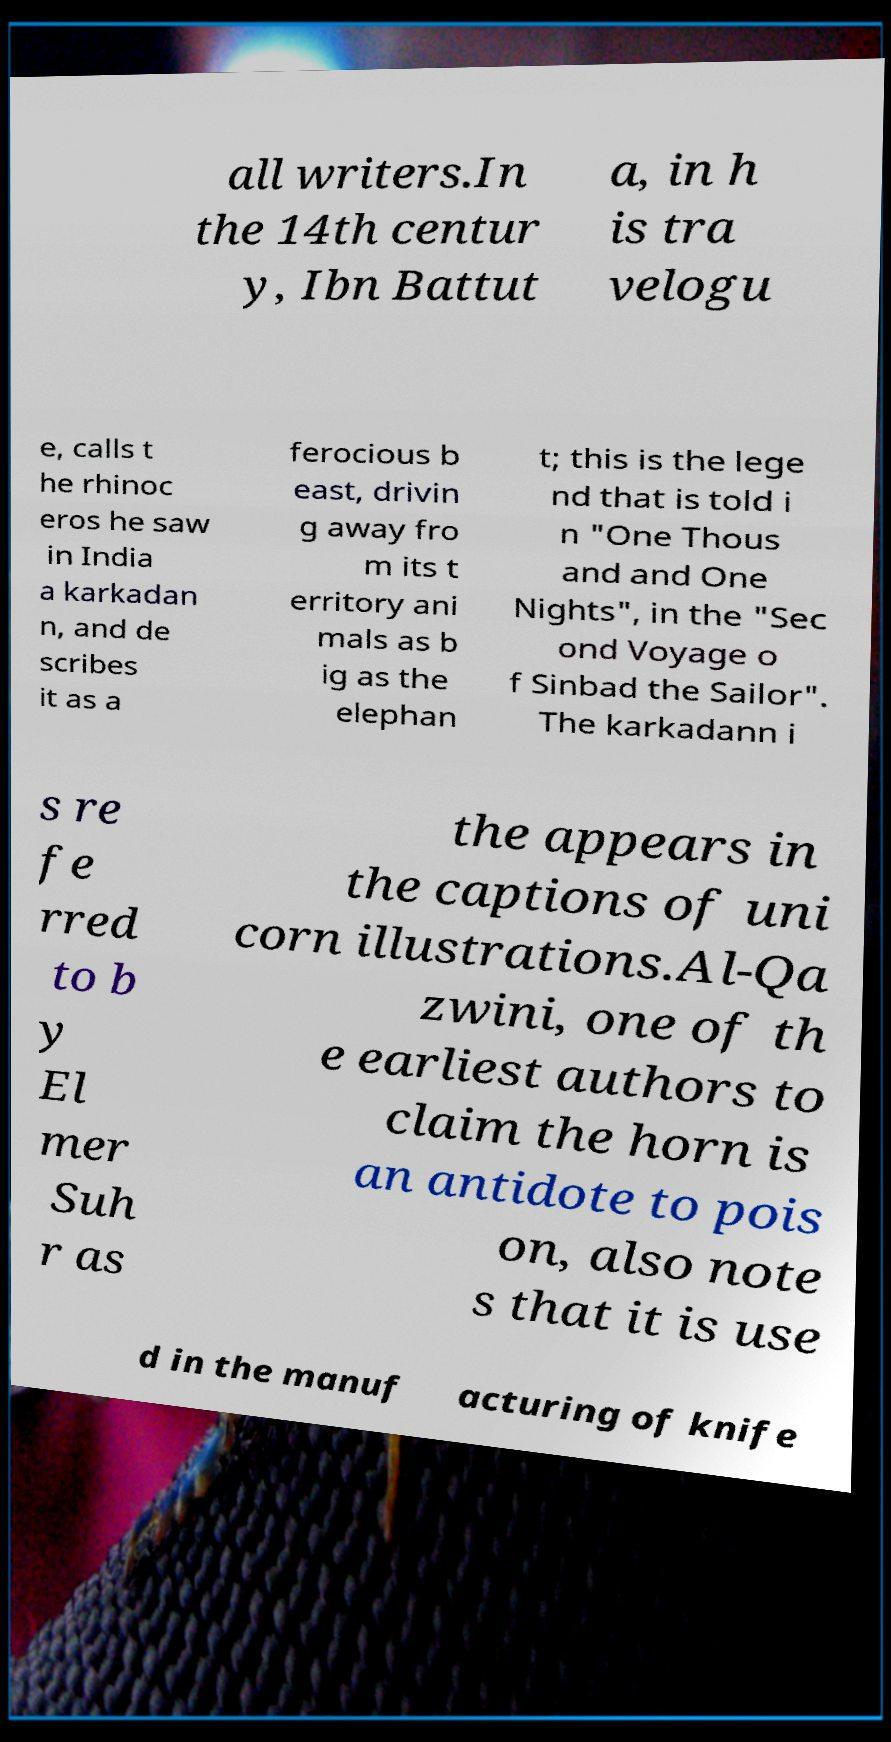What messages or text are displayed in this image? I need them in a readable, typed format. all writers.In the 14th centur y, Ibn Battut a, in h is tra velogu e, calls t he rhinoc eros he saw in India a karkadan n, and de scribes it as a ferocious b east, drivin g away fro m its t erritory ani mals as b ig as the elephan t; this is the lege nd that is told i n "One Thous and and One Nights", in the "Sec ond Voyage o f Sinbad the Sailor". The karkadann i s re fe rred to b y El mer Suh r as the appears in the captions of uni corn illustrations.Al-Qa zwini, one of th e earliest authors to claim the horn is an antidote to pois on, also note s that it is use d in the manuf acturing of knife 